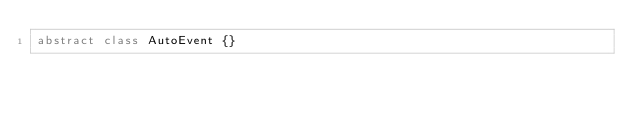Convert code to text. <code><loc_0><loc_0><loc_500><loc_500><_Dart_>abstract class AutoEvent {}

</code> 